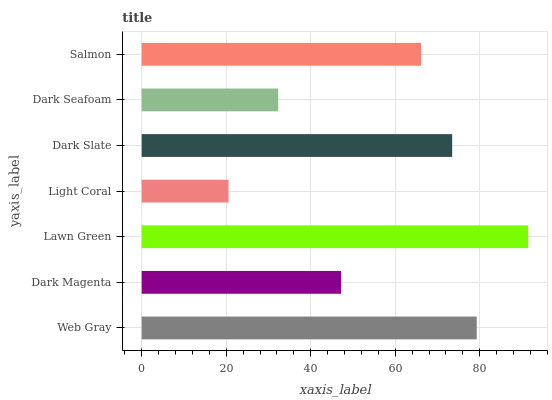Is Light Coral the minimum?
Answer yes or no. Yes. Is Lawn Green the maximum?
Answer yes or no. Yes. Is Dark Magenta the minimum?
Answer yes or no. No. Is Dark Magenta the maximum?
Answer yes or no. No. Is Web Gray greater than Dark Magenta?
Answer yes or no. Yes. Is Dark Magenta less than Web Gray?
Answer yes or no. Yes. Is Dark Magenta greater than Web Gray?
Answer yes or no. No. Is Web Gray less than Dark Magenta?
Answer yes or no. No. Is Salmon the high median?
Answer yes or no. Yes. Is Salmon the low median?
Answer yes or no. Yes. Is Dark Seafoam the high median?
Answer yes or no. No. Is Dark Slate the low median?
Answer yes or no. No. 